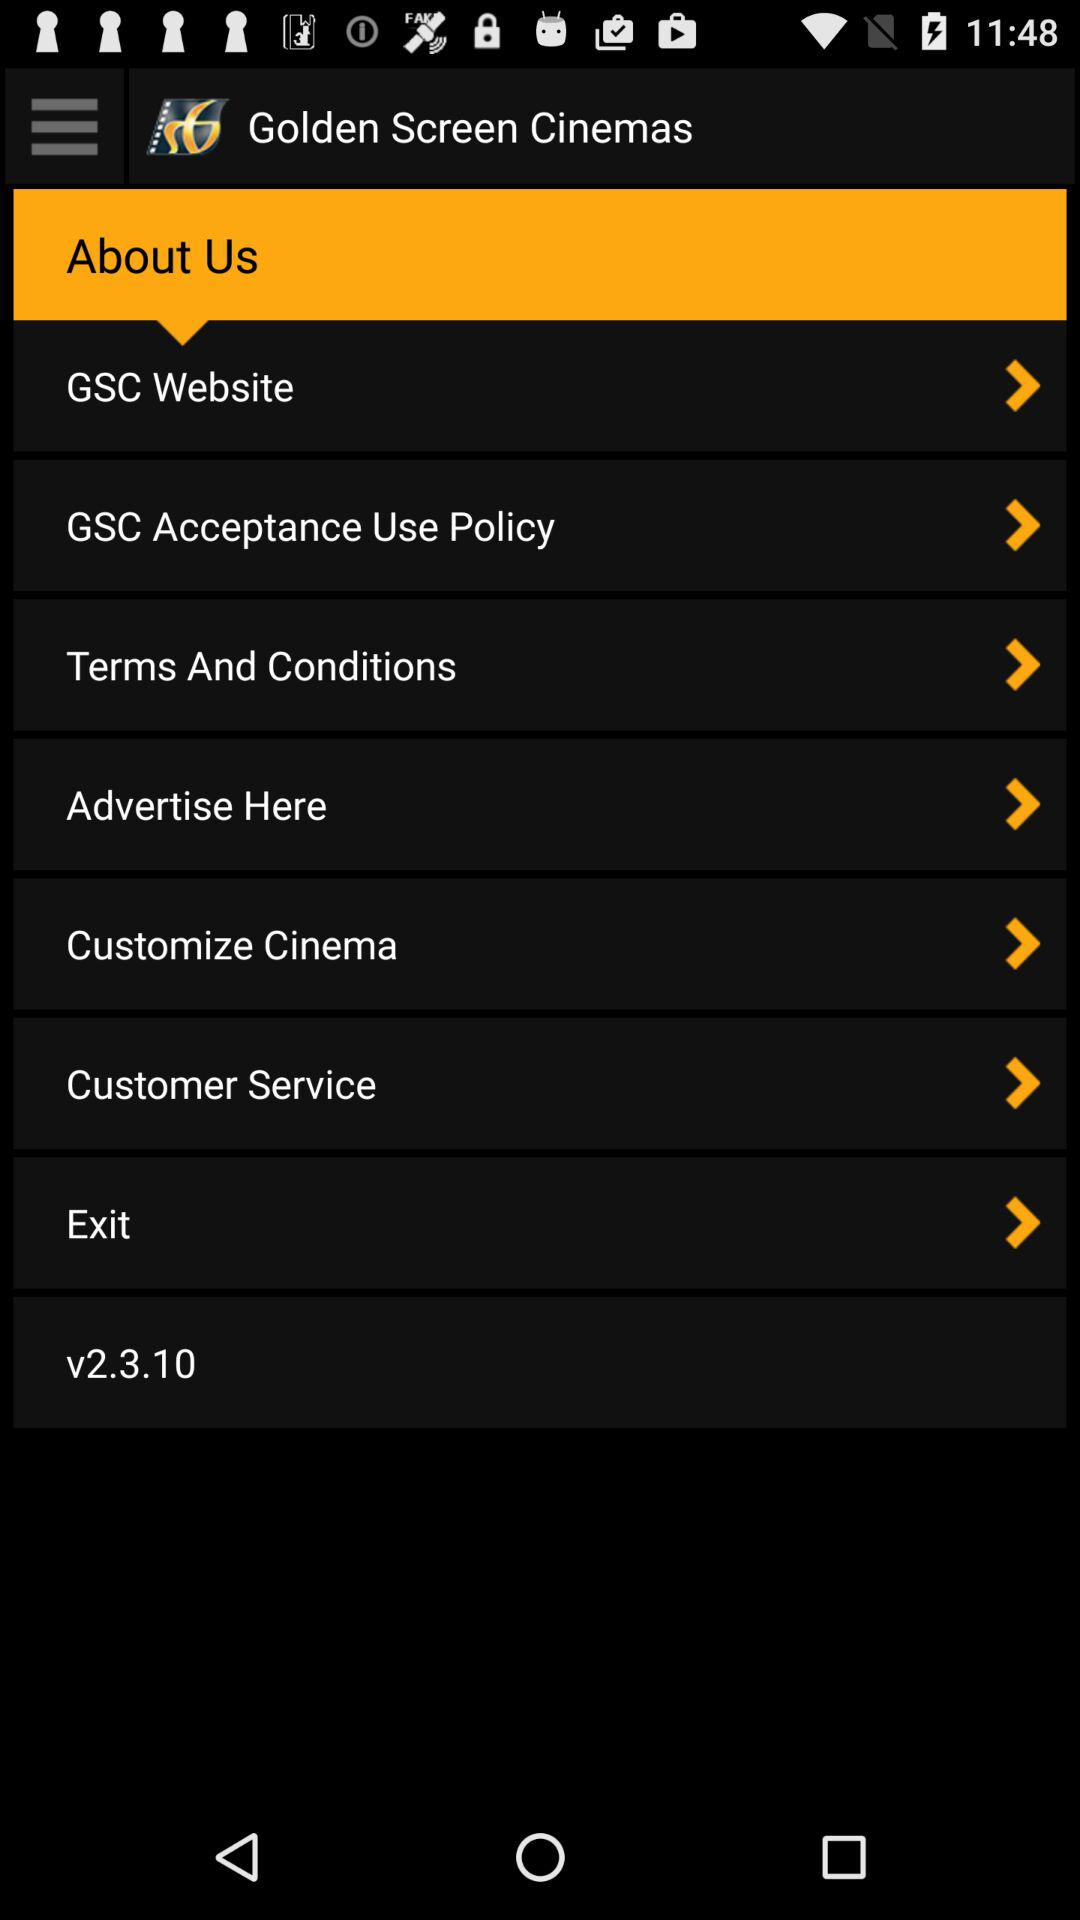What is the version of the app? The version of the app is v2.3.10. 